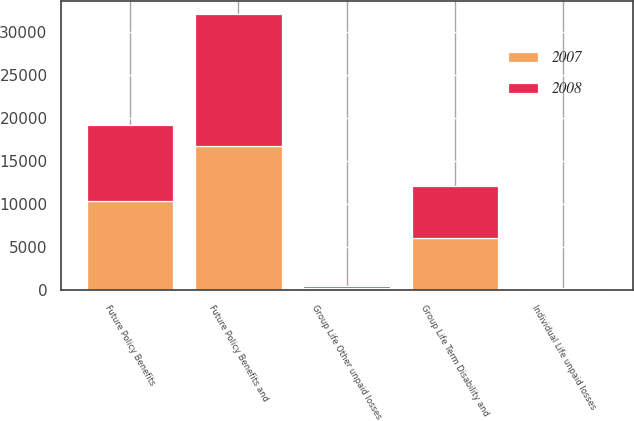Convert chart to OTSL. <chart><loc_0><loc_0><loc_500><loc_500><stacked_bar_chart><ecel><fcel>Group Life Term Disability and<fcel>Group Life Other unpaid losses<fcel>Individual Life unpaid losses<fcel>Future Policy Benefits<fcel>Future Policy Benefits and<nl><fcel>2007<fcel>6066<fcel>253<fcel>123<fcel>10305<fcel>16747<nl><fcel>2008<fcel>6028<fcel>269<fcel>121<fcel>8913<fcel>15331<nl></chart> 